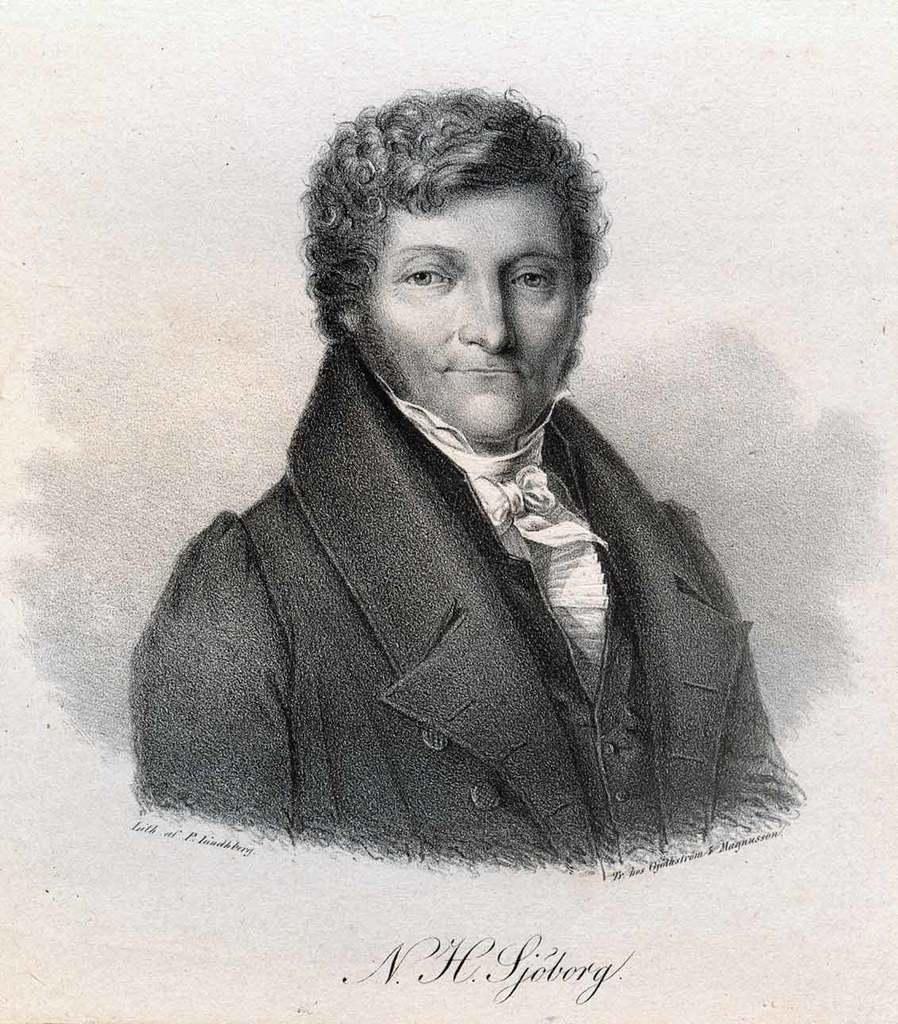What is the main subject of the image? The main subject of the image is a drawing of a person. Is there any text associated with the drawing? Yes, there is text written beneath the drawing. What type of card is being used to fan the person in the drawing? There is no card present in the image, and the person in the drawing is not being fanned. 